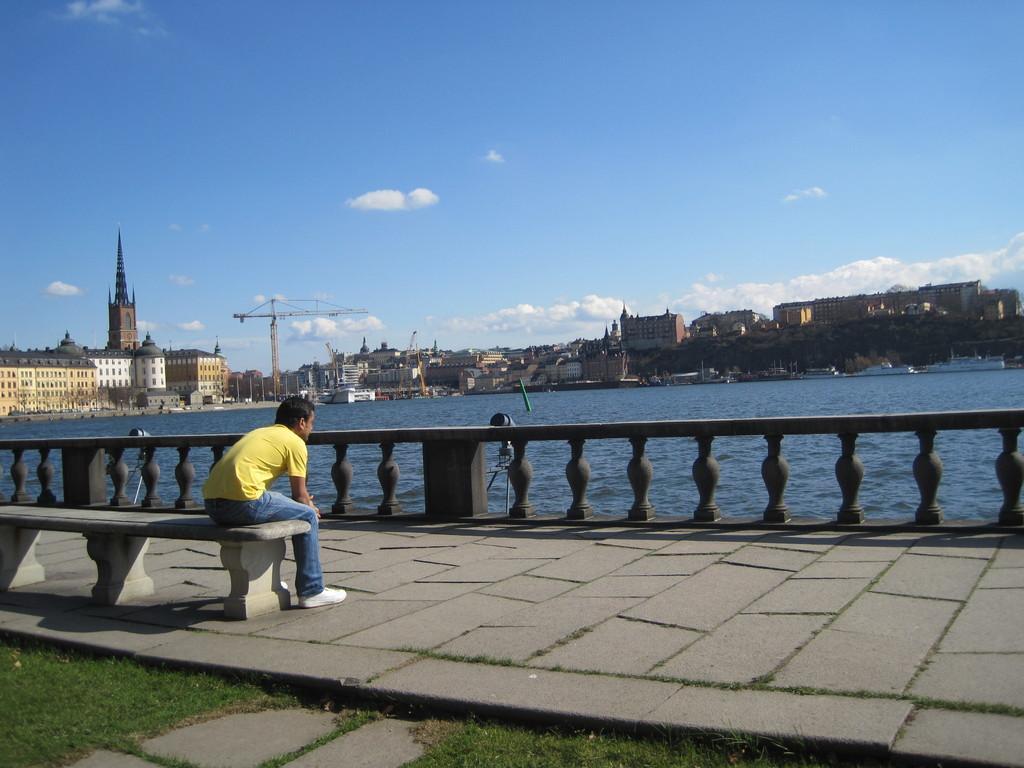Can you describe this image briefly? In this image there is a man sitting in bench and in back ground there is beach , road , building , tree, sky covered with clouds. 